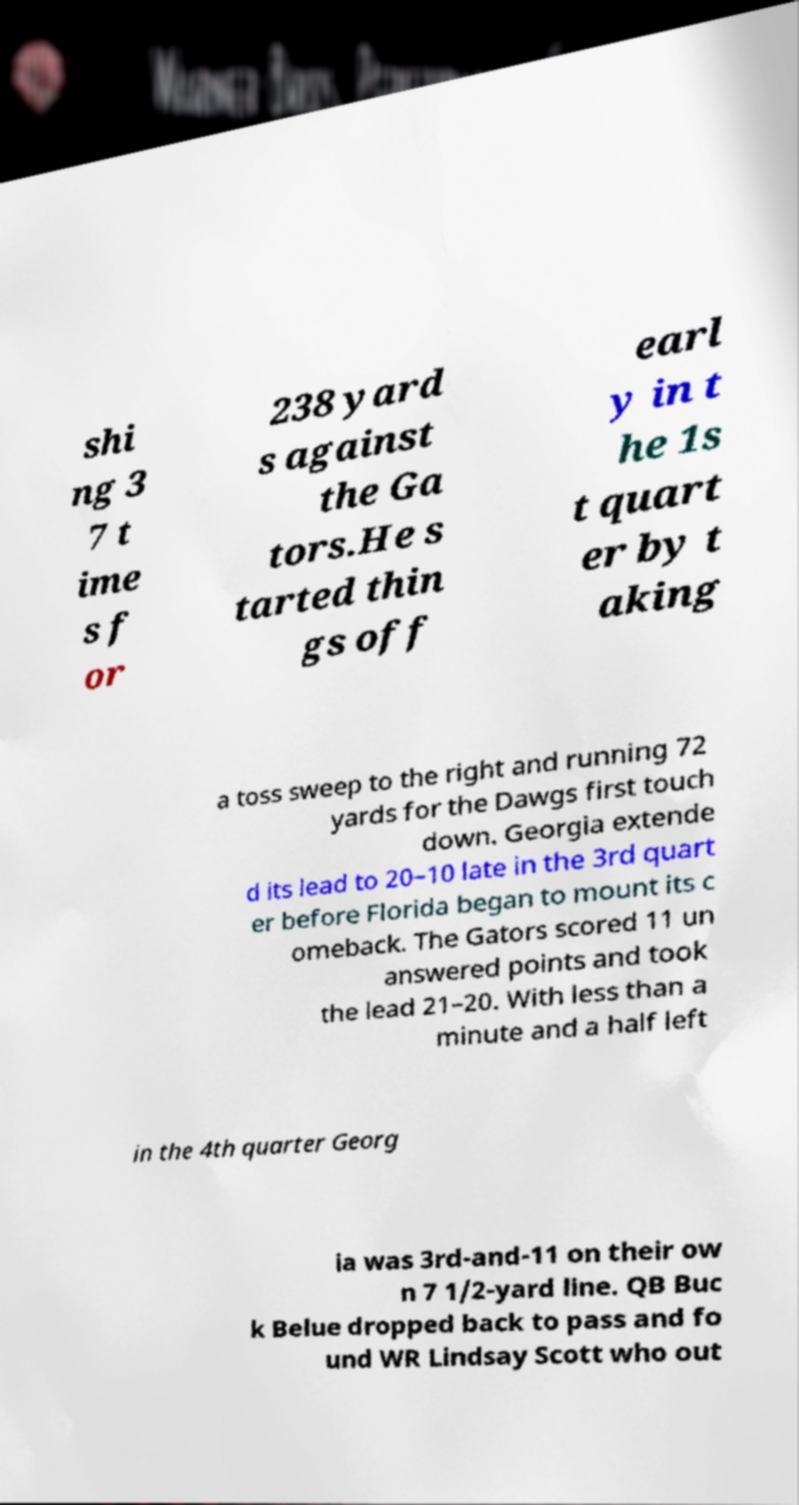Could you extract and type out the text from this image? shi ng 3 7 t ime s f or 238 yard s against the Ga tors.He s tarted thin gs off earl y in t he 1s t quart er by t aking a toss sweep to the right and running 72 yards for the Dawgs first touch down. Georgia extende d its lead to 20–10 late in the 3rd quart er before Florida began to mount its c omeback. The Gators scored 11 un answered points and took the lead 21–20. With less than a minute and a half left in the 4th quarter Georg ia was 3rd-and-11 on their ow n 7 1/2-yard line. QB Buc k Belue dropped back to pass and fo und WR Lindsay Scott who out 